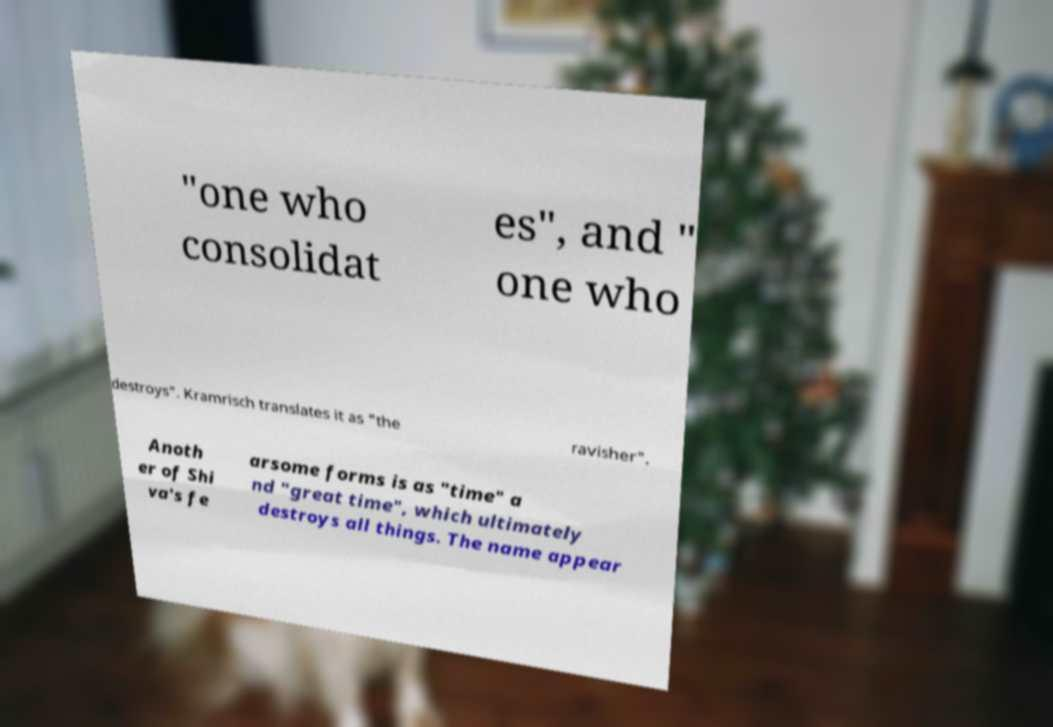Could you assist in decoding the text presented in this image and type it out clearly? "one who consolidat es", and " one who destroys". Kramrisch translates it as "the ravisher". Anoth er of Shi va's fe arsome forms is as "time" a nd "great time", which ultimately destroys all things. The name appear 